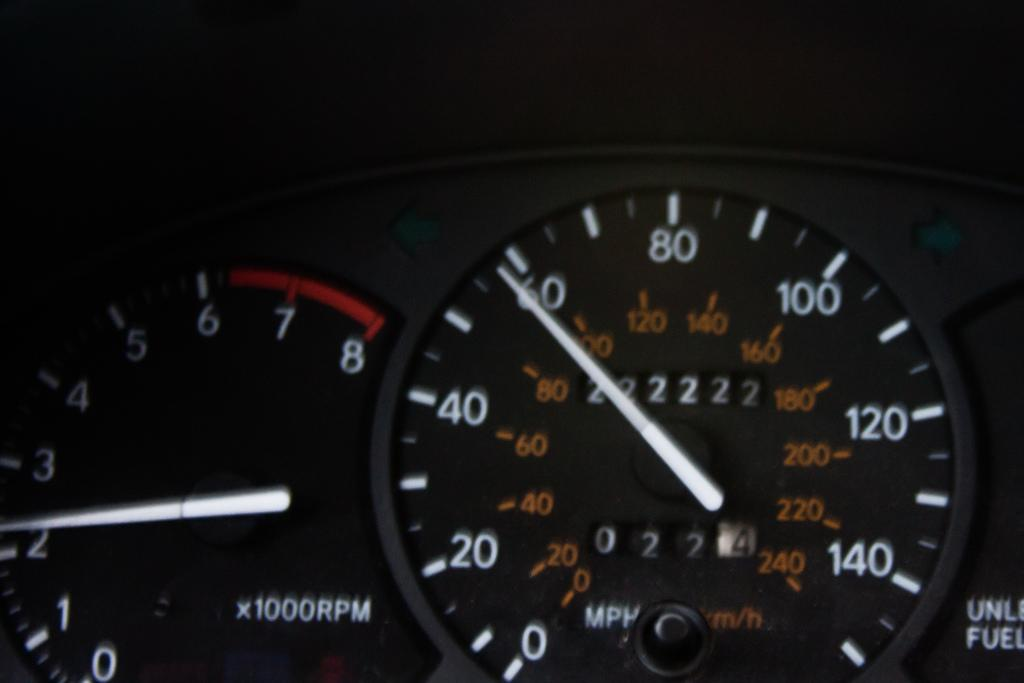What is the main subject of the image? The main subject of the image is a dash gauge. Can you read the caption on the cat in the image? There is no cat or caption present in the image; it features a dash gauge. 